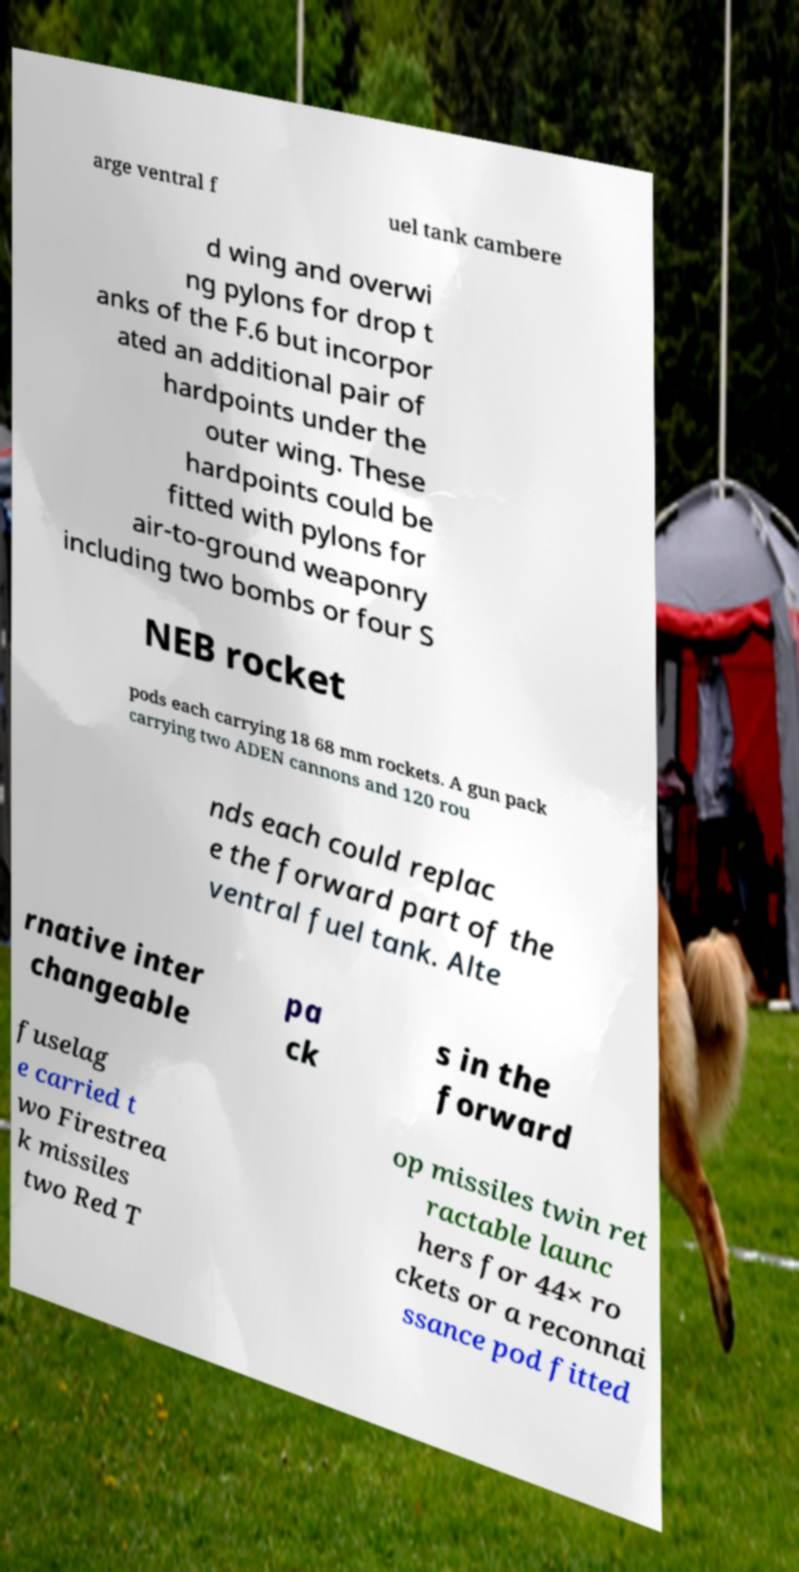Please read and relay the text visible in this image. What does it say? arge ventral f uel tank cambere d wing and overwi ng pylons for drop t anks of the F.6 but incorpor ated an additional pair of hardpoints under the outer wing. These hardpoints could be fitted with pylons for air-to-ground weaponry including two bombs or four S NEB rocket pods each carrying 18 68 mm rockets. A gun pack carrying two ADEN cannons and 120 rou nds each could replac e the forward part of the ventral fuel tank. Alte rnative inter changeable pa ck s in the forward fuselag e carried t wo Firestrea k missiles two Red T op missiles twin ret ractable launc hers for 44× ro ckets or a reconnai ssance pod fitted 